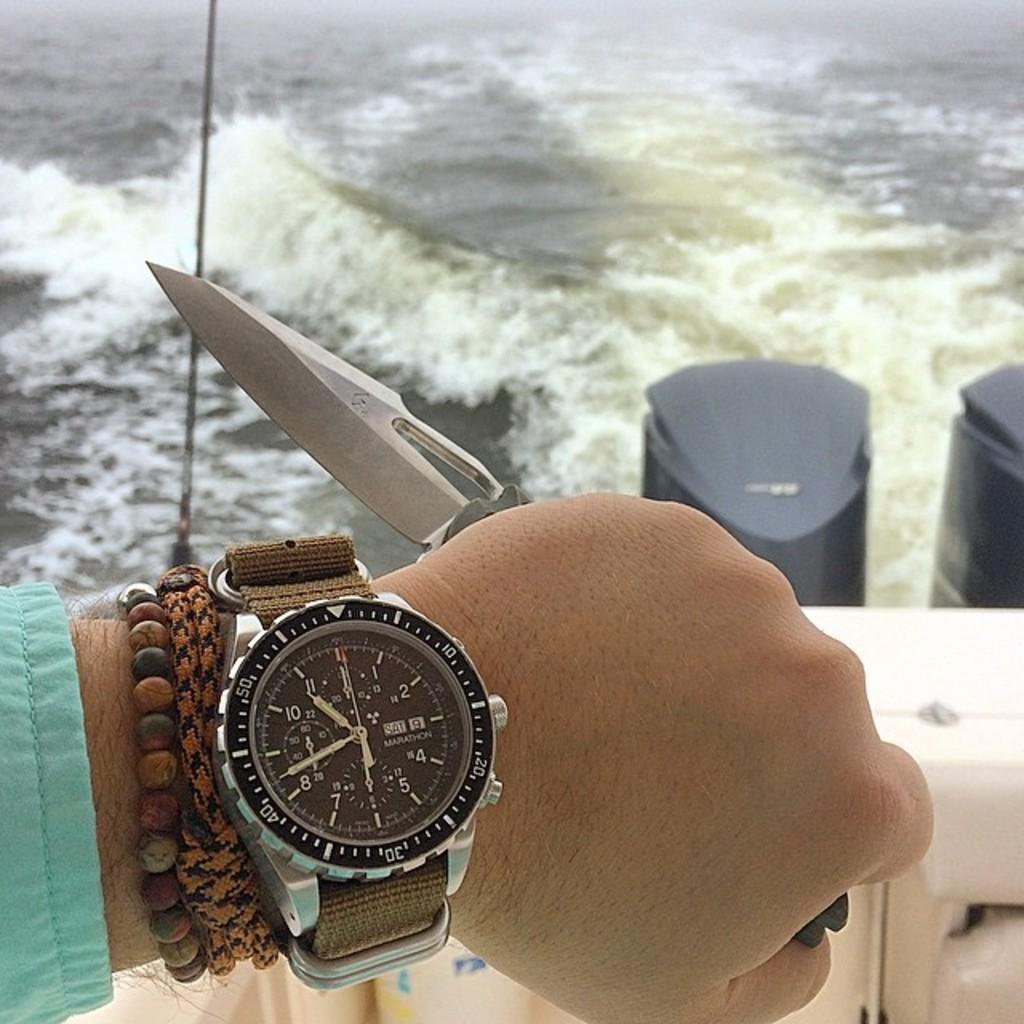Provide a one-sentence caption for the provided image. A person is showing their Marathon watch which is displaying the time. 